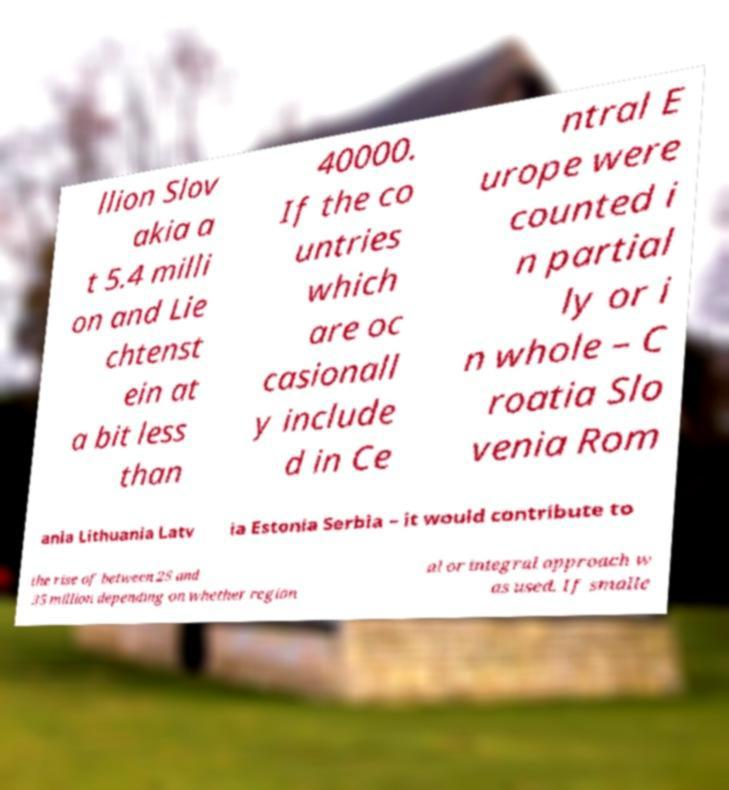I need the written content from this picture converted into text. Can you do that? llion Slov akia a t 5.4 milli on and Lie chtenst ein at a bit less than 40000. If the co untries which are oc casionall y include d in Ce ntral E urope were counted i n partial ly or i n whole – C roatia Slo venia Rom ania Lithuania Latv ia Estonia Serbia – it would contribute to the rise of between 25 and 35 million depending on whether region al or integral approach w as used. If smalle 